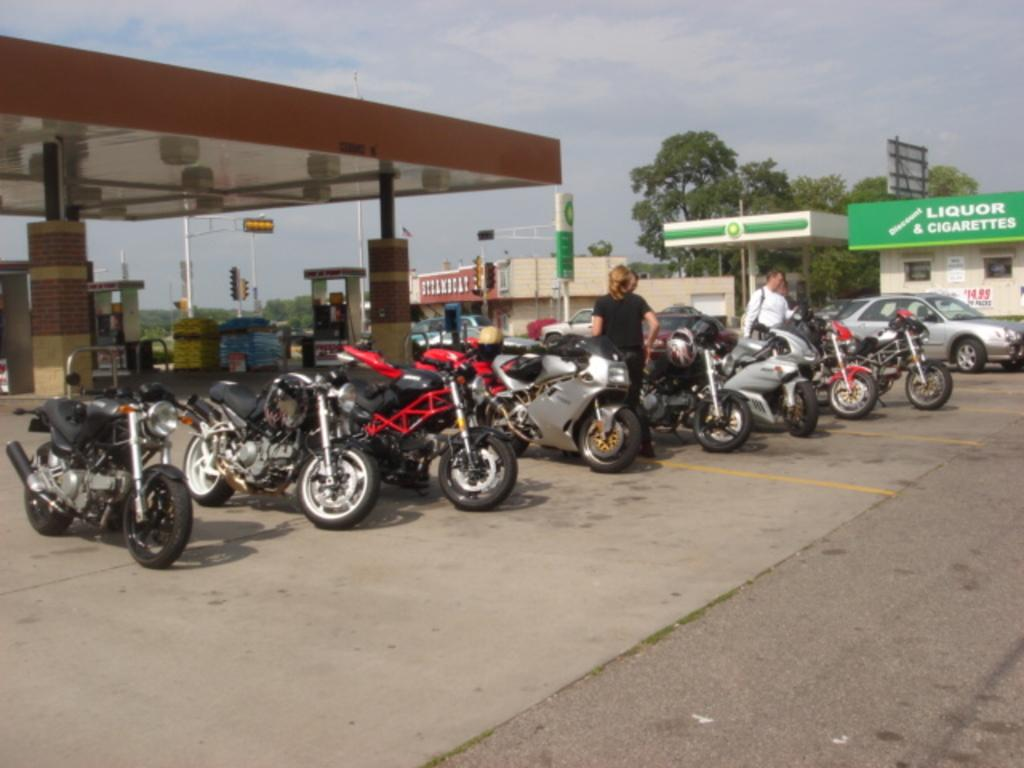What type of vehicles are present in the image? There are motorcycles and cars in the image. What can be found on the left side of the image? There is a petrol bunk on the left side of the image. What is located on the right side of the image? There are buildings on the right side of the image. What type of vegetation is present in the image? There are trees in the image. What is the condition of the sky in the image? The sky is clear in the image. Where is the gold bar hidden in the image? There is no gold bar present in the image. What tool is being used to fix the motorcycle in the image? There is no tool being used to fix a motorcycle in the image. 